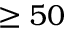Convert formula to latex. <formula><loc_0><loc_0><loc_500><loc_500>\geq 5 0</formula> 